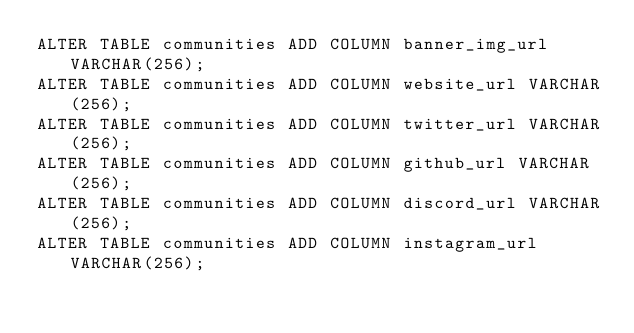Convert code to text. <code><loc_0><loc_0><loc_500><loc_500><_SQL_>ALTER TABLE communities ADD COLUMN banner_img_url VARCHAR(256);
ALTER TABLE communities ADD COLUMN website_url VARCHAR(256);
ALTER TABLE communities ADD COLUMN twitter_url VARCHAR(256);
ALTER TABLE communities ADD COLUMN github_url VARCHAR(256);
ALTER TABLE communities ADD COLUMN discord_url VARCHAR(256);
ALTER TABLE communities ADD COLUMN instagram_url VARCHAR(256);</code> 